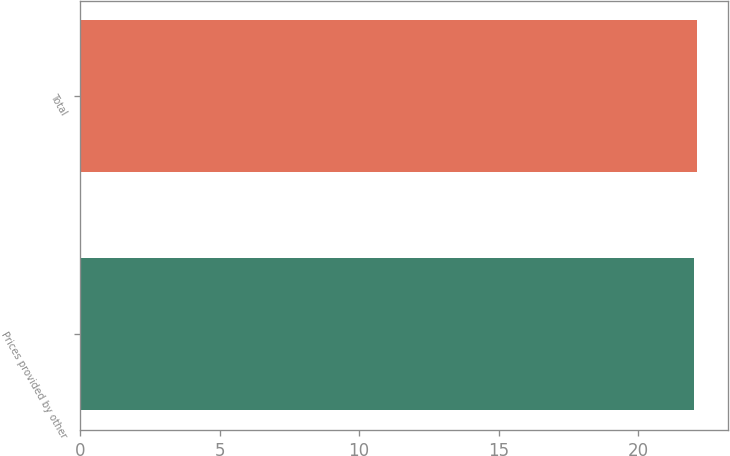<chart> <loc_0><loc_0><loc_500><loc_500><bar_chart><fcel>Prices provided by other<fcel>Total<nl><fcel>22<fcel>22.1<nl></chart> 